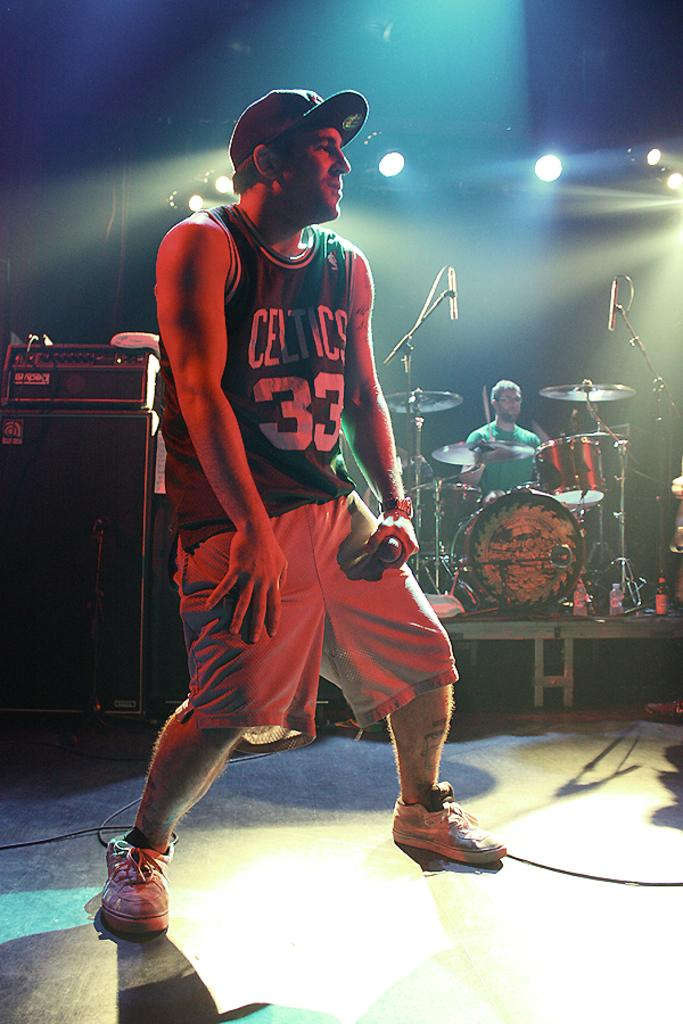What is the man in the image holding? The man is holding a mic. Can you describe the background of the image? In the background of the image, there is a person and musical instruments, as well as lights. What might the man be doing with the mic? The man might be using the mic to speak or sing. How many people are visible in the image? There is one man in the foreground and at least one person in the background, making a total of at least two people visible in the image. What type of stew is being prepared in the background of the image? There is no stew present in the image; it features a man holding a mic and a background with a person, musical instruments, and lights. How does the brain of the person in the background of the image look? There is no indication of the person's brain in the image, as it focuses on the man holding a mic and the background elements. 